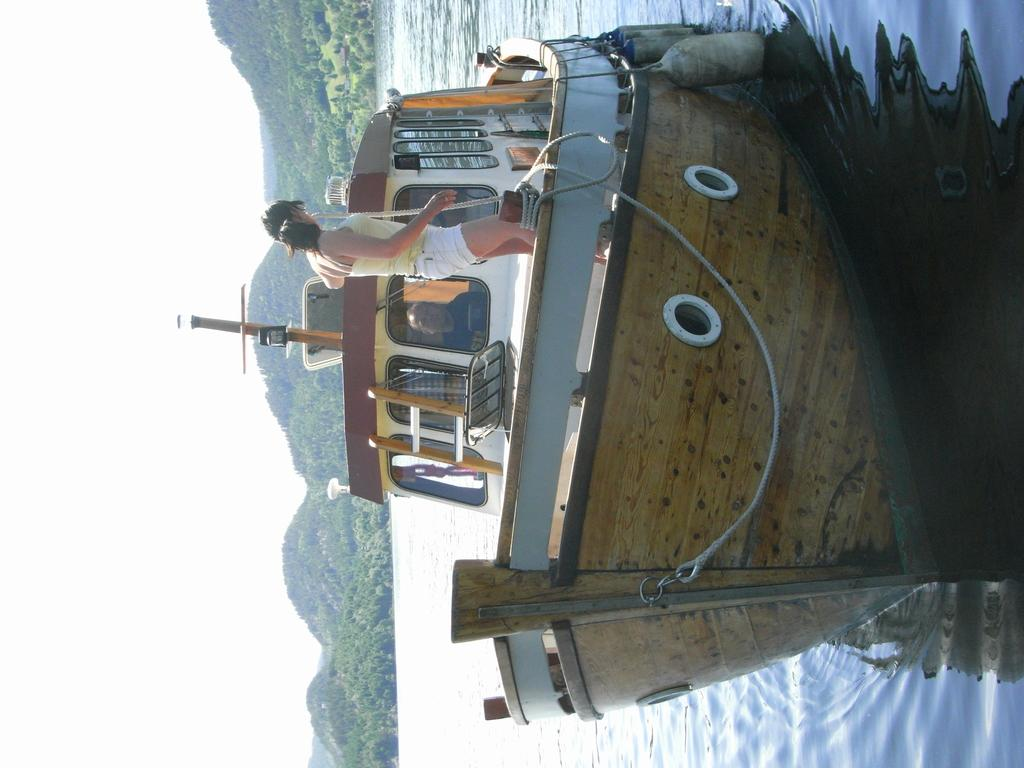What is the person doing in the image? There is a person standing on a boat in the image. Where is the boat located? The boat is on the water. What can be seen in the background of the image? There are mountains visible in the background. What sound does the goat make in the image? There is no goat present in the image, so it is not possible to determine the sound it might make. 